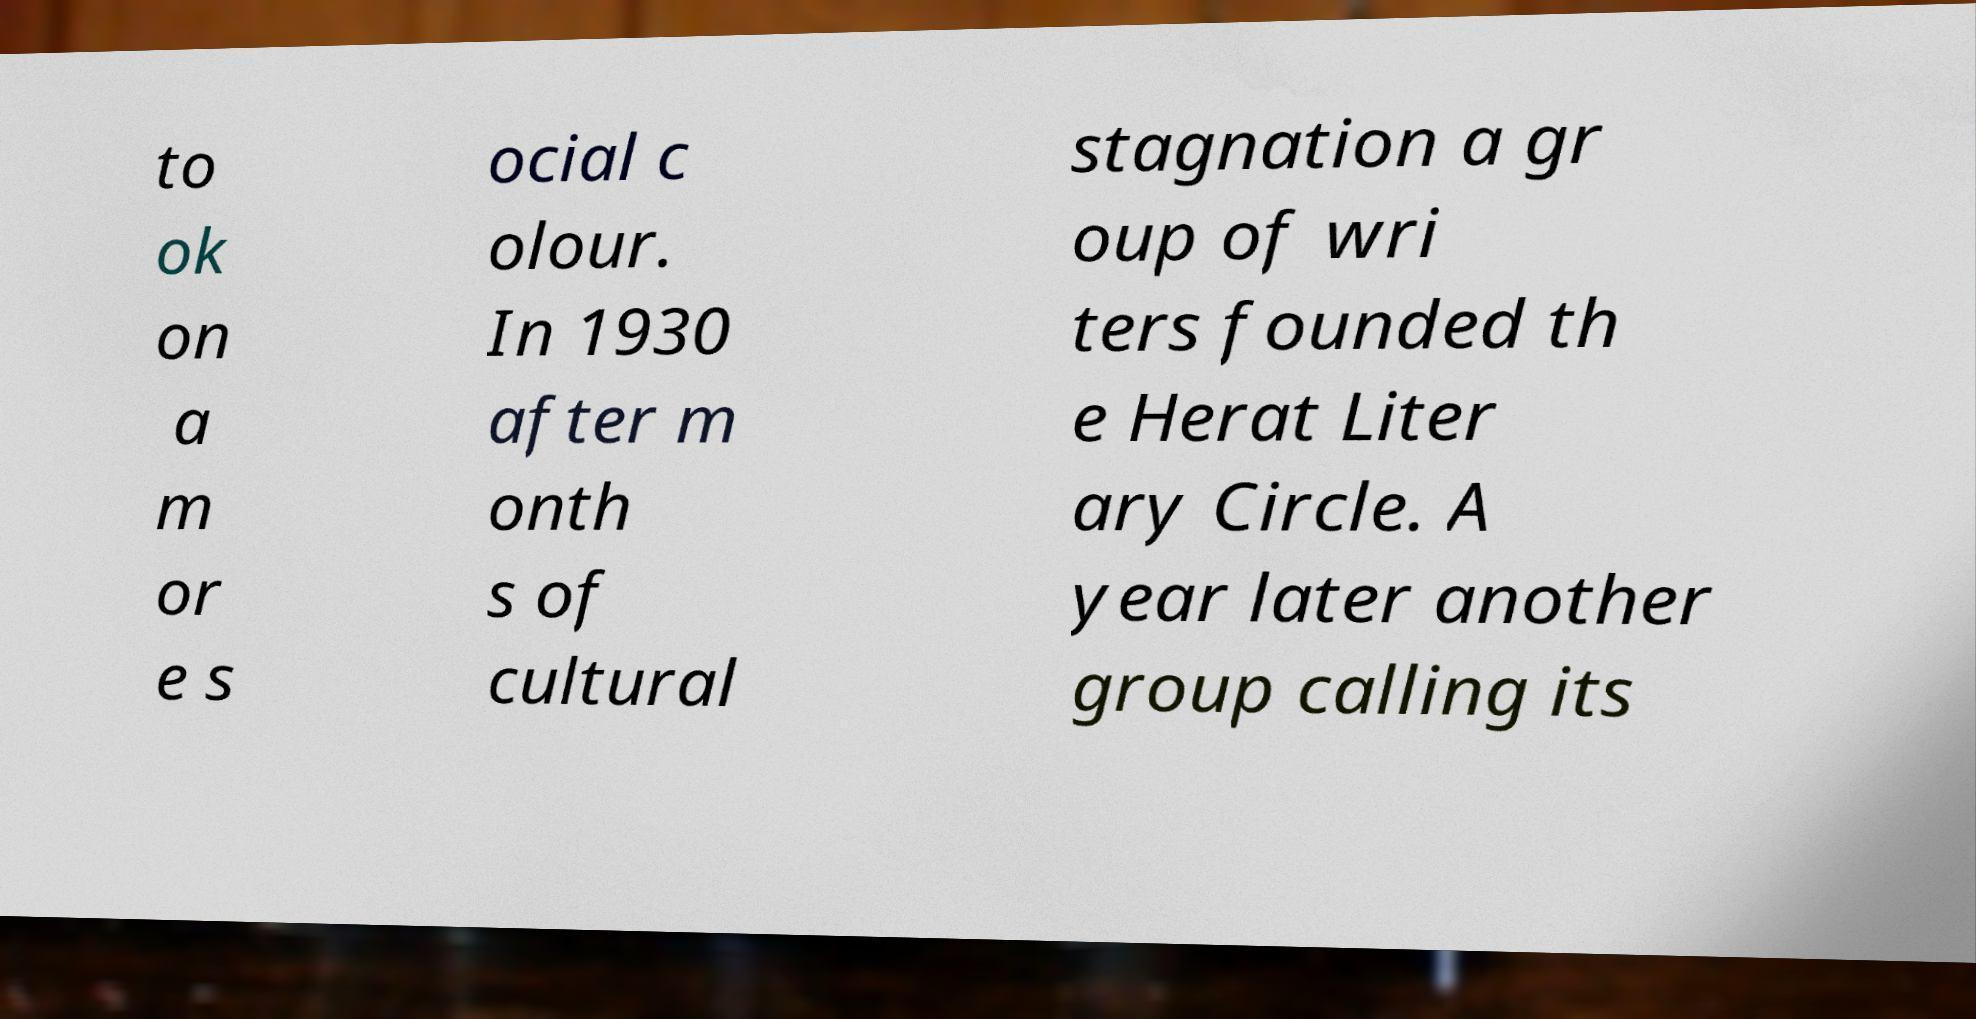Can you accurately transcribe the text from the provided image for me? to ok on a m or e s ocial c olour. In 1930 after m onth s of cultural stagnation a gr oup of wri ters founded th e Herat Liter ary Circle. A year later another group calling its 